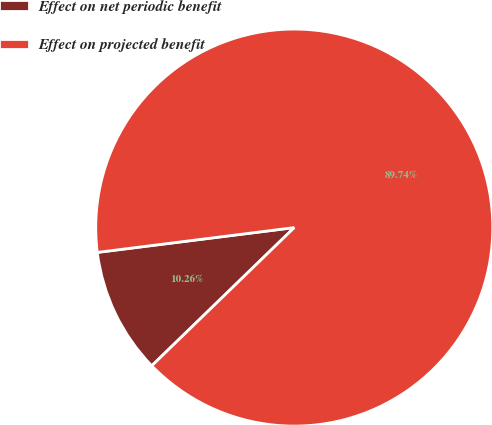Convert chart. <chart><loc_0><loc_0><loc_500><loc_500><pie_chart><fcel>Effect on net periodic benefit<fcel>Effect on projected benefit<nl><fcel>10.26%<fcel>89.74%<nl></chart> 